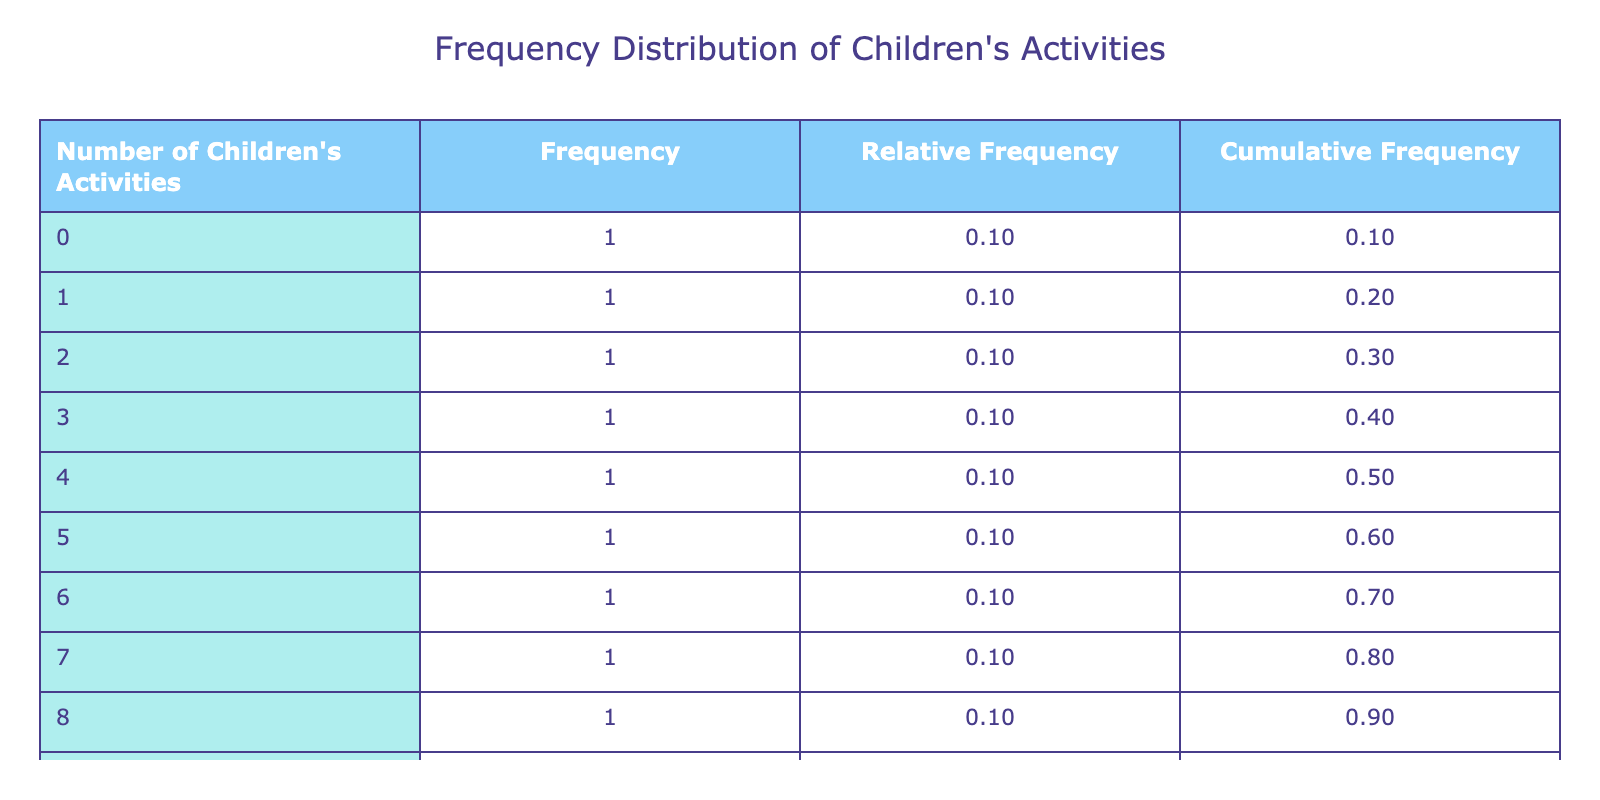What is the frequency of children participating in 0 activities? Referring to the table, the frequency for 0 children's activities is listed as 1.
Answer: 1 How many comedy gigs were performed when 5 children's activities were participated in? From the table, the number of comedy gigs for 5 children's activities is shown as 10.
Answer: 10 What is the relative frequency of children participating in 2 activities? The frequency for 2 activities is 1, and since the total frequency is 10, the relative frequency is calculated as 1/10, which is 0.10.
Answer: 0.10 What is the cumulative frequency for children participating in 3 activities? To find the cumulative frequency for 3 activities, we sum the frequencies for 0, 1, 2, and 3 activities, which are: 1 (0) + 1 (1) + 1 (2) + 1 (3) = 4.
Answer: 4 Is it true that more comedy gigs were performed compared to children's activities participated in for 8 activities? For 8 activities, 6 comedy gigs were performed, which is less than the number of activities (8), so it is false.
Answer: No What is the average number of comedy gigs performed across all children's activity participation levels? The total number of comedy gigs is 10 + 8 + 12 + 9 + 7 + 6 + 15 + 14 + 5 + 20 = 96, and with 10 activity counts, the average is 96/10 = 9.6.
Answer: 9.6 How many children participated in either 6 or 9 activities altogether? Adding the frequencies for 6 (1) and 9 (1) activities gives us 1 + 1 = 2.
Answer: 2 What is the highest number of comedy gigs performed for any number of children's activities? The highest number of comedy gigs listed in the table is 20, which occurred when 0 activities were participated in.
Answer: 20 If the frequency for children participating in 4 activities was increased by 1, what would the new cumulative frequency be for that count? The new frequency for 4 would be 2 (originally 1), leading to a cumulative frequency for up to 4 being (1+1+1+2) = 5.
Answer: 5 